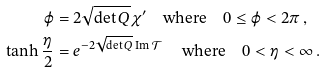Convert formula to latex. <formula><loc_0><loc_0><loc_500><loc_500>\varphi & = 2 \sqrt { \text {det} \, Q } \chi ^ { \prime } \quad \text {where} \quad 0 \leq \varphi < 2 \pi \, , \\ \tanh \frac { \eta } { 2 } & = e ^ { - 2 \sqrt { \text {det} \, Q } \, \text {Im} \, \mathcal { T } } \, \quad \text {where} \quad 0 < \eta < \infty \, .</formula> 